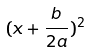Convert formula to latex. <formula><loc_0><loc_0><loc_500><loc_500>( x + \frac { b } { 2 a } ) ^ { 2 }</formula> 